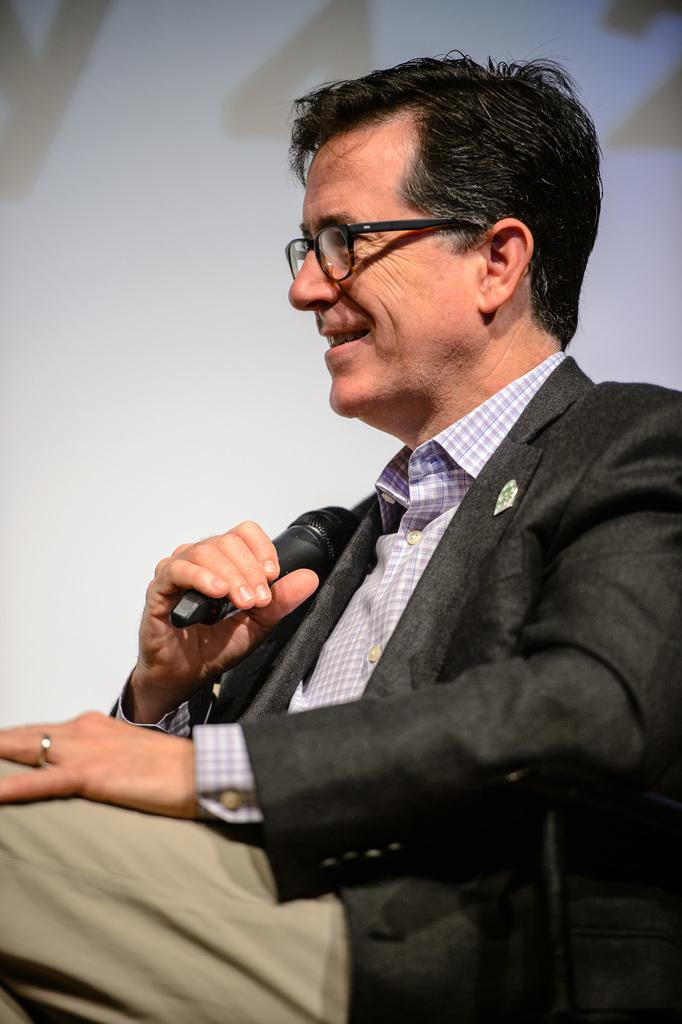What is the main subject of the image? There is a person in the image. What is the person holding in their hand? The person is holding a microphone in their hand. What can be seen in the background of the image? There is a wall in the background of the image. Where might this image have been taken? The image may have been taken in a hall, given the presence of a wall and the person holding a microphone. What type of pest can be seen crawling on the wall in the image? There is no pest visible on the wall in the image. Is there a drain visible in the image? There is no drain present in the image. 